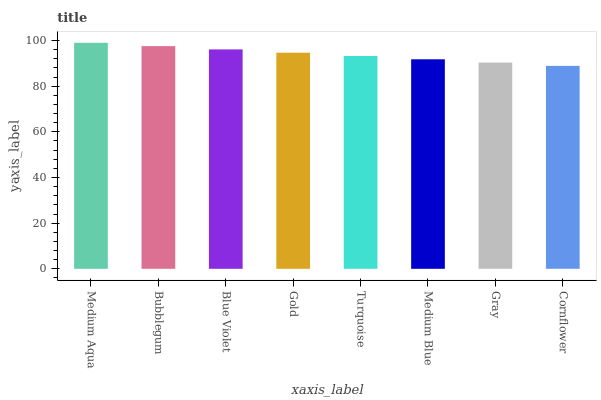Is Cornflower the minimum?
Answer yes or no. Yes. Is Medium Aqua the maximum?
Answer yes or no. Yes. Is Bubblegum the minimum?
Answer yes or no. No. Is Bubblegum the maximum?
Answer yes or no. No. Is Medium Aqua greater than Bubblegum?
Answer yes or no. Yes. Is Bubblegum less than Medium Aqua?
Answer yes or no. Yes. Is Bubblegum greater than Medium Aqua?
Answer yes or no. No. Is Medium Aqua less than Bubblegum?
Answer yes or no. No. Is Gold the high median?
Answer yes or no. Yes. Is Turquoise the low median?
Answer yes or no. Yes. Is Gray the high median?
Answer yes or no. No. Is Medium Blue the low median?
Answer yes or no. No. 